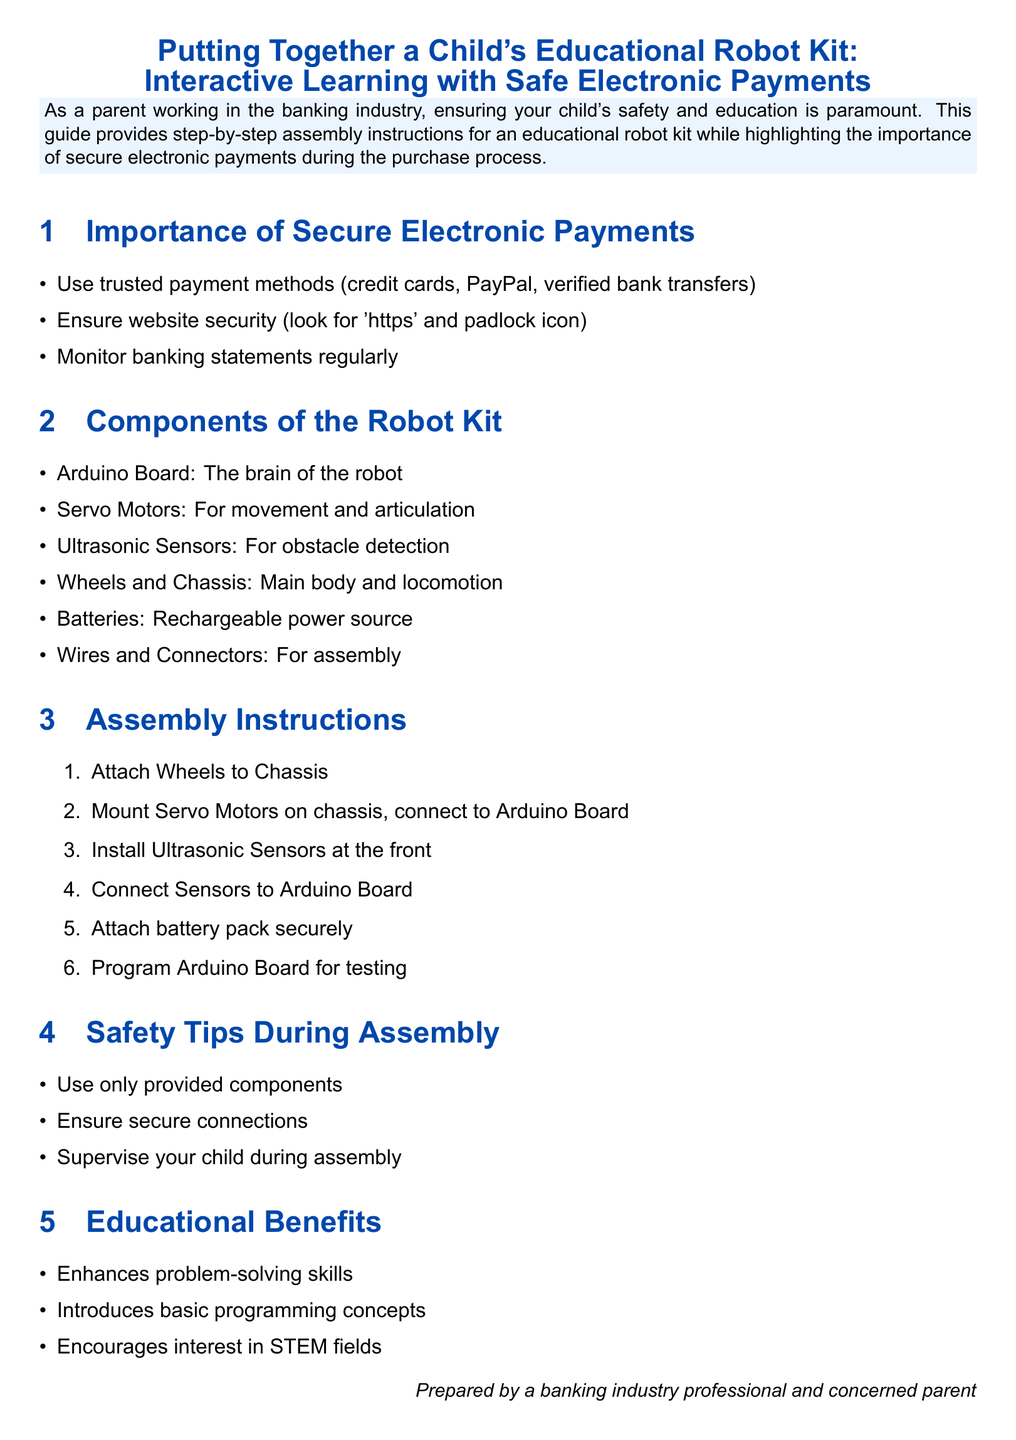What is the first step in the assembly instructions? The first step listed in the assembly instructions is to attach the wheels to the chassis.
Answer: Attach Wheels to Chassis What is a component of the robot kit? The document lists multiple components of the robot kit, including the Arduino Board, which is referred to as the brain of the robot.
Answer: Arduino Board What must be checked for website security during payment? The document advises checking for 'https' and a padlock icon on the website to ensure security during payment.
Answer: 'https' and padlock icon How many items are included in the components list? The document includes a list of six components that make up the robot kit.
Answer: Six What is one of the safety tips during assembly? One of the safety tips mentioned is to use only the provided components during assembly.
Answer: Use only provided components What educational benefit does the document highlight? The document emphasizes that the robot kit enhances problem-solving skills as one of the key educational benefits.
Answer: Enhances problem-solving skills What type of payment methods are recommended? Trusted payment methods such as credit cards, PayPal, and verified bank transfers are recommended in the document.
Answer: Credit cards, PayPal, verified bank transfers What is the purpose of the ultrasonic sensors? The ultrasonic sensors are used for obstacle detection in the robot kit.
Answer: Obstacle detection How should parents supervise during assembly? Parents are advised to supervise their children during the assembly process to ensure safety.
Answer: Supervise your child during assembly 